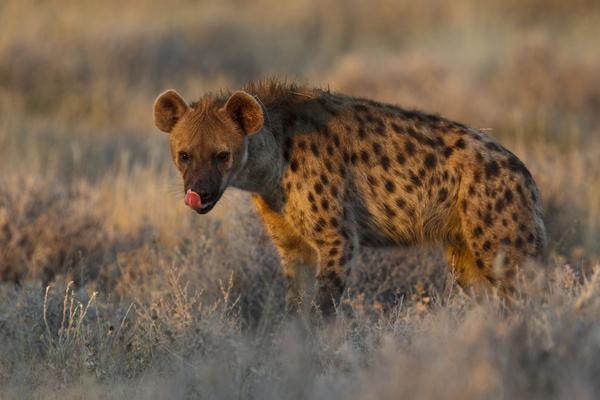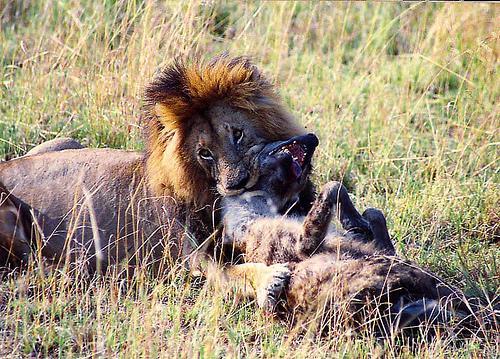The first image is the image on the left, the second image is the image on the right. For the images displayed, is the sentence "A hyena is standing in a field in the image on the left." factually correct? Answer yes or no. Yes. 